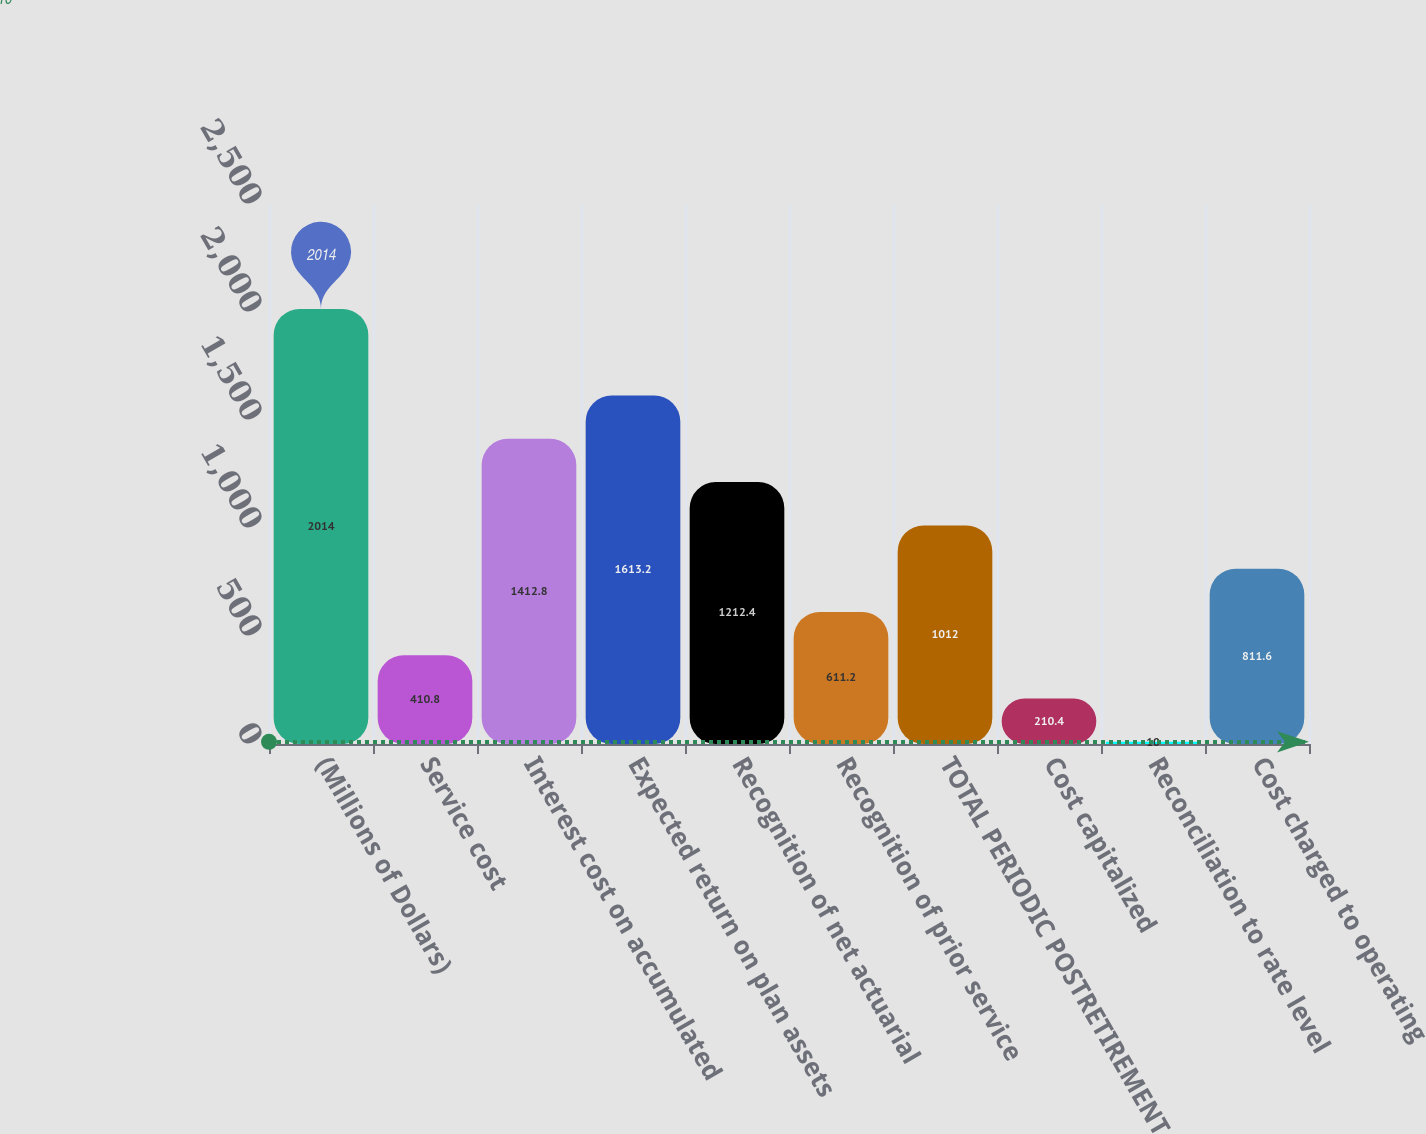<chart> <loc_0><loc_0><loc_500><loc_500><bar_chart><fcel>(Millions of Dollars)<fcel>Service cost<fcel>Interest cost on accumulated<fcel>Expected return on plan assets<fcel>Recognition of net actuarial<fcel>Recognition of prior service<fcel>TOTAL PERIODIC POSTRETIREMENT<fcel>Cost capitalized<fcel>Reconciliation to rate level<fcel>Cost charged to operating<nl><fcel>2014<fcel>410.8<fcel>1412.8<fcel>1613.2<fcel>1212.4<fcel>611.2<fcel>1012<fcel>210.4<fcel>10<fcel>811.6<nl></chart> 